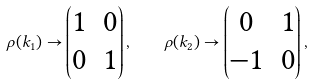Convert formula to latex. <formula><loc_0><loc_0><loc_500><loc_500>\rho ( k _ { 1 } ) \to \begin{pmatrix} 1 & 0 \\ 0 & 1 \end{pmatrix} , \quad \rho ( k _ { 2 } ) \to \begin{pmatrix} 0 & 1 \\ - 1 & 0 \end{pmatrix} ,</formula> 